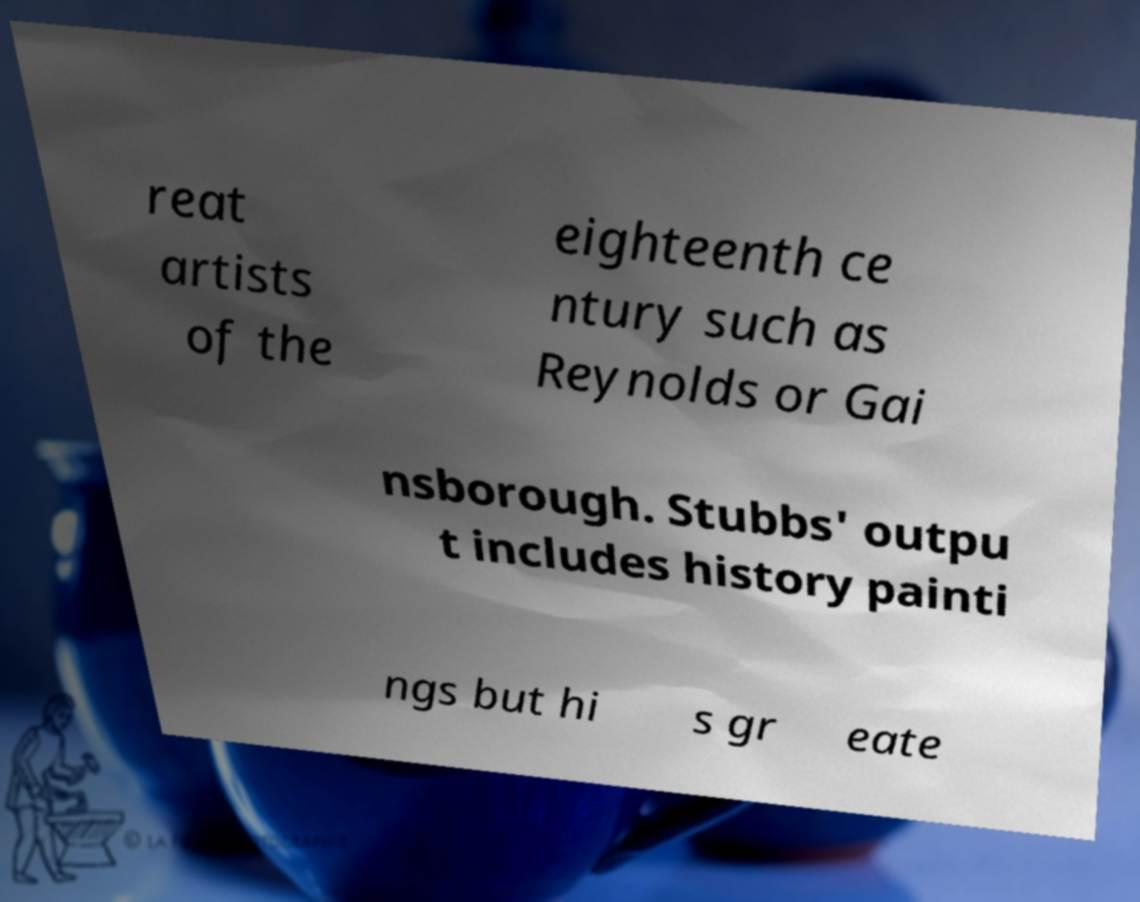Can you accurately transcribe the text from the provided image for me? reat artists of the eighteenth ce ntury such as Reynolds or Gai nsborough. Stubbs' outpu t includes history painti ngs but hi s gr eate 